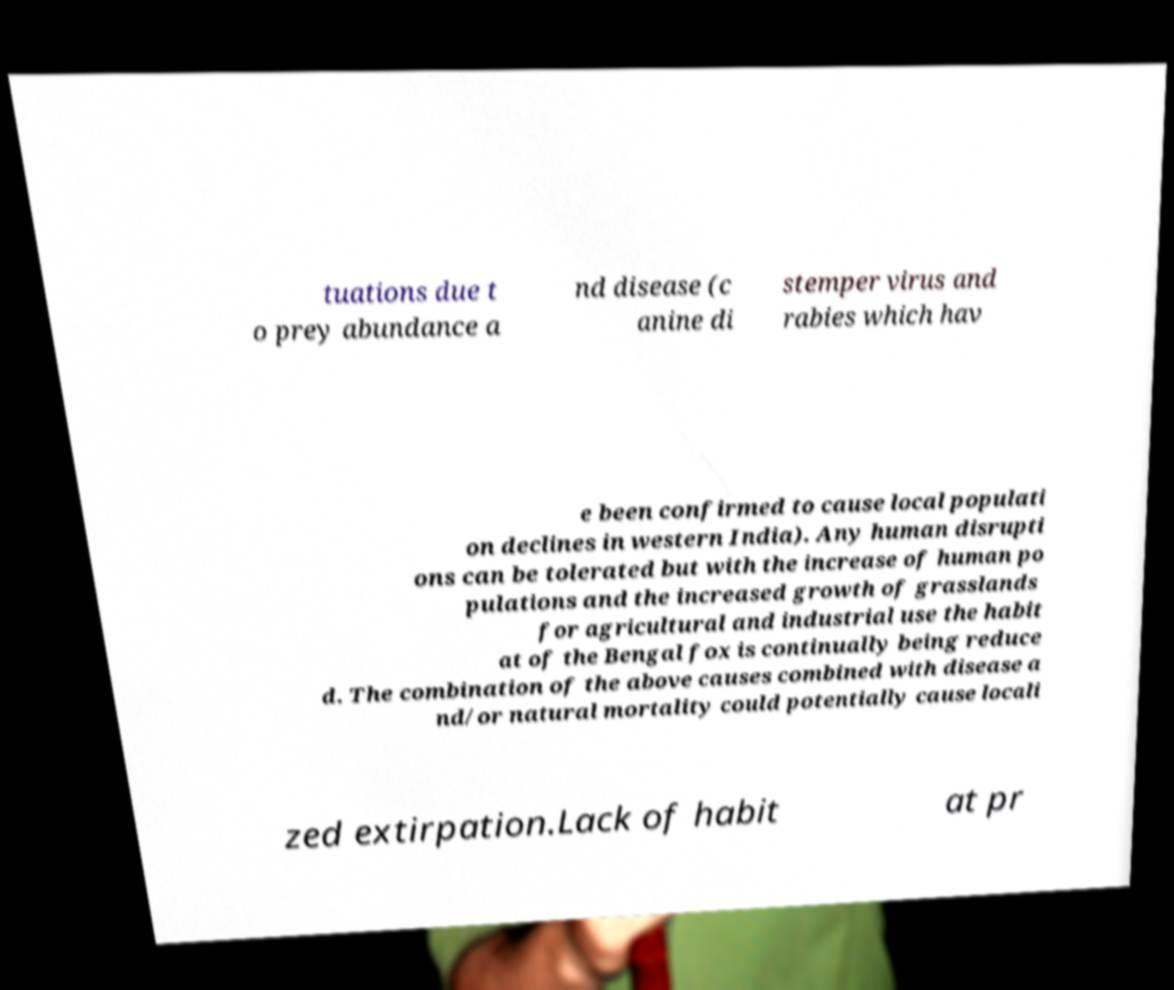Could you assist in decoding the text presented in this image and type it out clearly? tuations due t o prey abundance a nd disease (c anine di stemper virus and rabies which hav e been confirmed to cause local populati on declines in western India). Any human disrupti ons can be tolerated but with the increase of human po pulations and the increased growth of grasslands for agricultural and industrial use the habit at of the Bengal fox is continually being reduce d. The combination of the above causes combined with disease a nd/or natural mortality could potentially cause locali zed extirpation.Lack of habit at pr 